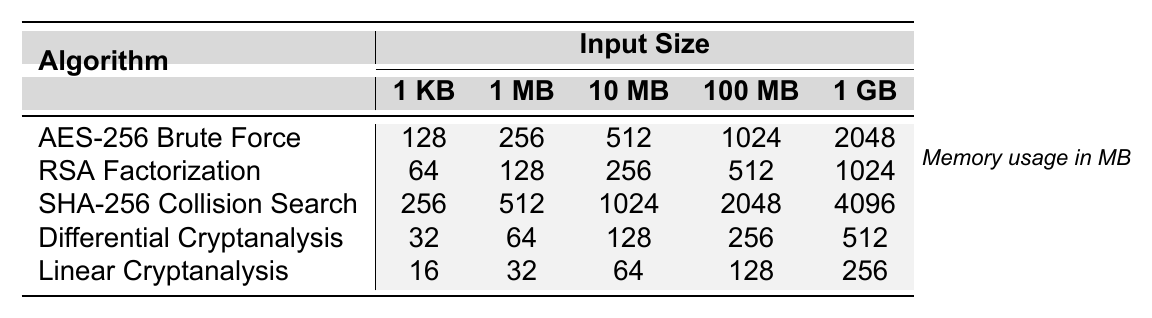What is the memory usage of the AES-256 Brute Force algorithm for an input size of 10 MB? From the table, the memory usage of the AES-256 Brute Force algorithm for the input size of 10 MB is directly listed as 512 MB.
Answer: 512 MB What is the memory usage of the Linear Cryptanalysis algorithm for the largest input size? The largest input size is 1 GB, and the memory usage for Linear Cryptanalysis at this input size is listed as 256 MB in the table.
Answer: 256 MB Which algorithm requires the least memory usage for an input size of 1 MB? Looking across the row for the 1 MB input size, Linear Cryptanalysis has the lowest memory usage of 32 MB compared to the other algorithms.
Answer: 32 MB What is the difference in memory usage between SHA-256 Collision Search and RSA Factorization for an input size of 1 GB? For 1 GB, SHA-256 Collision Search uses 4096 MB while RSA Factorization uses 1024 MB. The difference is 4096 - 1024 = 3072 MB.
Answer: 3072 MB True or False: The memory usage for Differential Cryptanalysis increases by more than 100 MB as the input size goes from 100 MB to 1 GB. The memory usage for Differential Cryptanalysis is 256 MB at 100 MB input size and 512 MB at 1 GB input size. The increase is 512 - 256 = 256 MB, which is not more than 100 MB.
Answer: False What are the total memory usages for all algorithms at the input size of 1 KB? Adding the memory usages at 1 KB, we have 128 + 64 + 256 + 32 + 16 = 496 MB total memory usage.
Answer: 496 MB Which algorithm shows the highest memory usage at the input size of 100 MB? Referring to the table, the SHA-256 Collision Search algorithm has the highest memory usage at 2048 MB for the input size of 100 MB.
Answer: SHA-256 Collision Search What is the average memory usage of all algorithms for an input size of 1 MB? The memory usages for 1 MB are: 256 (AES-256), 128 (RSA), 512 (SHA-256), 64 (Differential), and 32 (Linear). To find the average, sum them: 256 + 128 + 512 + 64 + 32 = 992 MB and divide by 5, which results in 198.4 MB.
Answer: 198.4 MB How many times more memory does the SHA-256 Collision Search use for an input size of 1 GB compared to Linear Cryptanalysis for the same input size? For 1 GB, SHA-256 Collision Search uses 4096 MB and Linear Cryptanalysis uses 256 MB. The ratio is 4096 / 256 = 16, meaning SHA-256 uses 16 times more memory.
Answer: 16 times Which algorithm has the lowest memory usage increase from 1 KB to 1 GB? The algorithm with the lowest increase can be found by comparing each algorithm's memory usage change from 1 KB (where Linear uses 16 MB) to 1 GB (where it uses 256 MB). The increase is 256 - 16 = 240 MB, which is lower than any other increase from the other algorithms.
Answer: Linear Cryptanalysis 